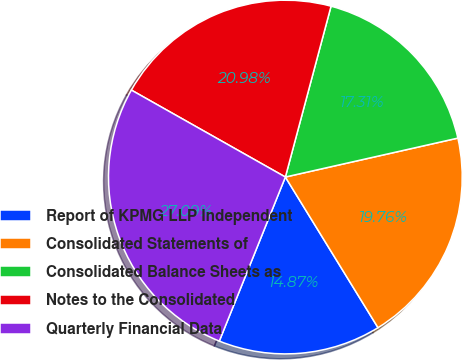Convert chart to OTSL. <chart><loc_0><loc_0><loc_500><loc_500><pie_chart><fcel>Report of KPMG LLP Independent<fcel>Consolidated Statements of<fcel>Consolidated Balance Sheets as<fcel>Notes to the Consolidated<fcel>Quarterly Financial Data<nl><fcel>14.87%<fcel>19.76%<fcel>17.31%<fcel>20.98%<fcel>27.09%<nl></chart> 